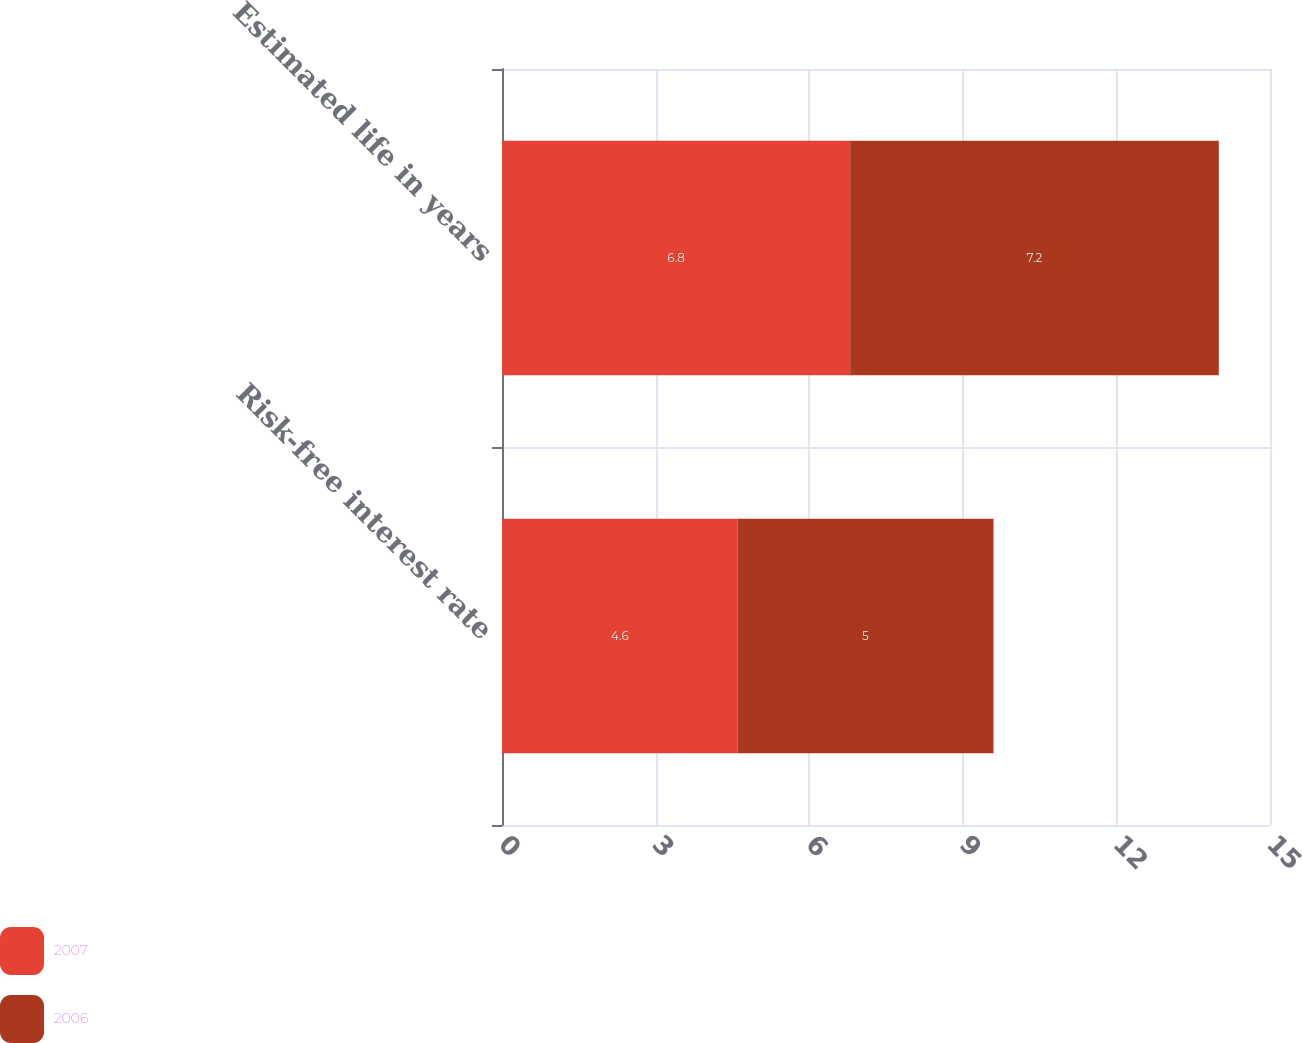<chart> <loc_0><loc_0><loc_500><loc_500><stacked_bar_chart><ecel><fcel>Risk-free interest rate<fcel>Estimated life in years<nl><fcel>2007<fcel>4.6<fcel>6.8<nl><fcel>2006<fcel>5<fcel>7.2<nl></chart> 